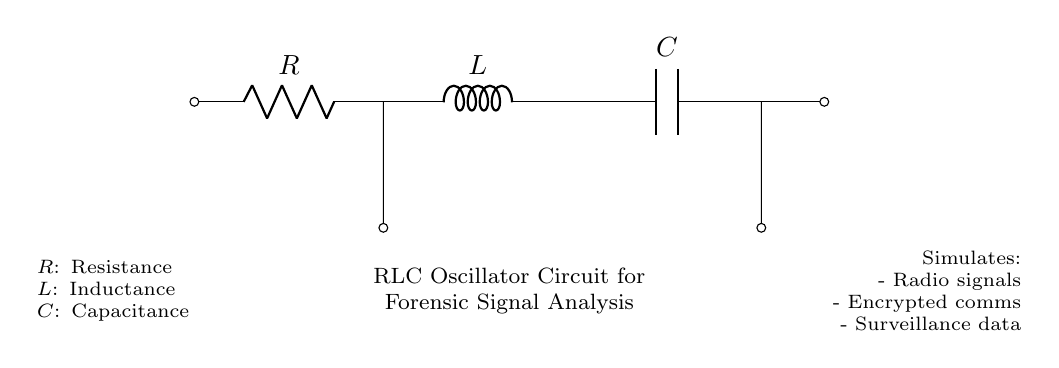What is the value of resistance in this circuit? The circuit diagram includes a resistor denoted by "R", but the specific numerical value is not provided in the visual representation.
Answer: R What component indicates inductance? The component representing inductance is labeled "L" in the diagram, which is a standard notation for an inductor.
Answer: L What is the role of the capacitor in this circuit? The capacitor, labeled "C", stores electrical energy temporarily and releases it, impacting the oscillation frequency of the circuit.
Answer: Energy storage What types of signals can this circuit simulate? The diagram specifies that the circuit is capable of simulating radio signals, encrypted communications, and surveillance data, as indicated in the notes.
Answer: Radio signals, encrypted coms, surveillance data How do R, L, and C work together in this oscillator? In an RLC oscillator, resistance provides damping, inductance stores energy in a magnetic field, and capacitance stores energy in an electric field, collectively creating oscillations at a natural frequency.
Answer: Damping, energy storage, oscillations What is the primary application of the RLC oscillator in forensic analysis? The circuit is utilized to simulate various communication signal types for forensic analysis, aiding in the investigation of electronic communications.
Answer: Forensic signal analysis 